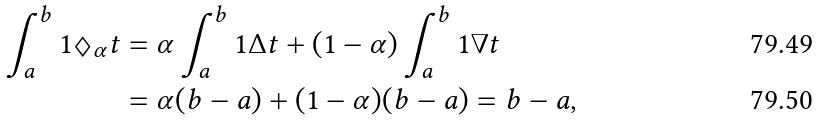<formula> <loc_0><loc_0><loc_500><loc_500>\int _ { a } ^ { b } 1 \Diamond _ { \alpha } t & = \alpha \int _ { a } ^ { b } 1 \Delta t + ( 1 - \alpha ) \int _ { a } ^ { b } 1 \nabla t \\ & = \alpha ( b - a ) + ( 1 - \alpha ) ( b - a ) = b - a ,</formula> 